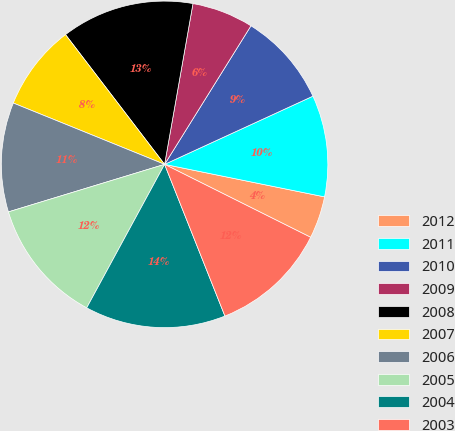Convert chart to OTSL. <chart><loc_0><loc_0><loc_500><loc_500><pie_chart><fcel>2012<fcel>2011<fcel>2010<fcel>2009<fcel>2008<fcel>2007<fcel>2006<fcel>2005<fcel>2004<fcel>2003<nl><fcel>4.18%<fcel>10.05%<fcel>9.27%<fcel>6.09%<fcel>13.16%<fcel>8.49%<fcel>10.83%<fcel>12.38%<fcel>13.94%<fcel>11.6%<nl></chart> 